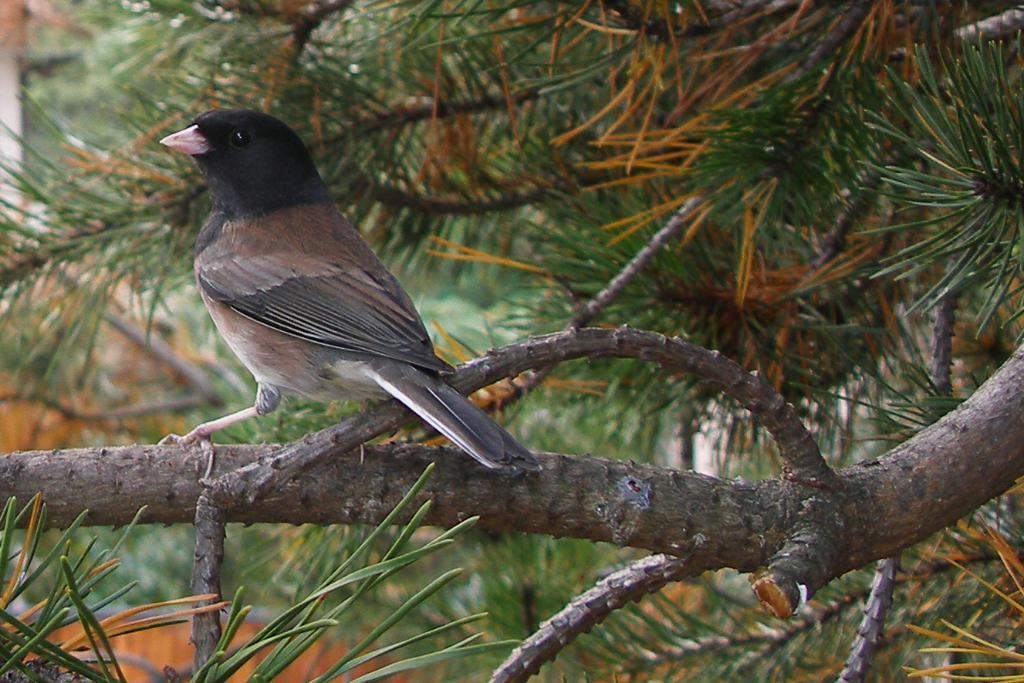What is the main subject of focus of the image? There is a bird in the center of the image. Where is the bird located? The bird is on a tree. What can be seen in the background of the image? There is a house and trees visible in the background of the image. What type of force is being exerted on the bird by the society in the image? There is no mention of society or any force being exerted on the bird in the image. The bird is simply perched on a tree. 